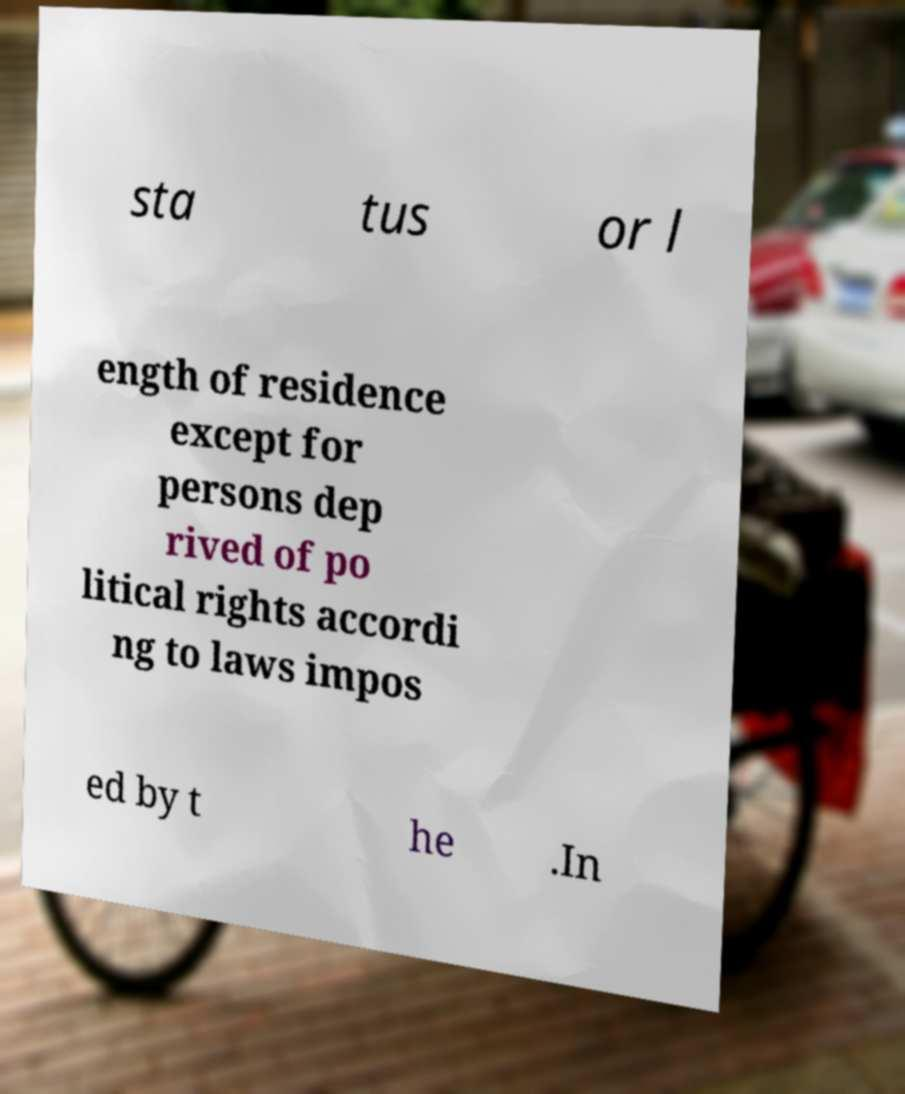Can you accurately transcribe the text from the provided image for me? sta tus or l ength of residence except for persons dep rived of po litical rights accordi ng to laws impos ed by t he .In 